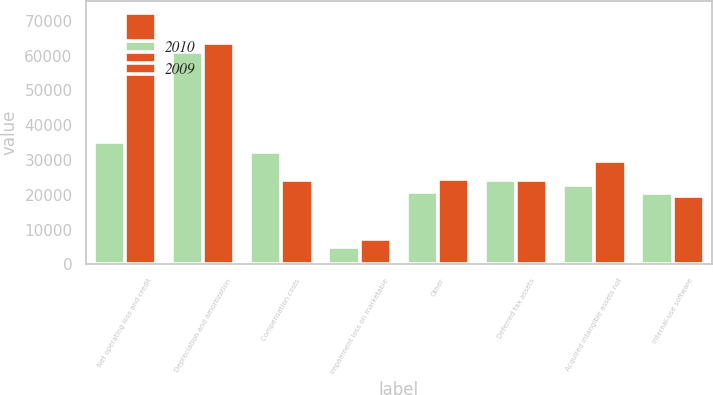Convert chart. <chart><loc_0><loc_0><loc_500><loc_500><stacked_bar_chart><ecel><fcel>Net operating loss and credit<fcel>Depreciation and amortization<fcel>Compensation costs<fcel>Impairment loss on marketable<fcel>Other<fcel>Deferred tax assets<fcel>Acquired intangible assets not<fcel>Internal-use software<nl><fcel>2010<fcel>35202<fcel>60935<fcel>32221<fcel>5005<fcel>20782<fcel>24368<fcel>22784<fcel>20527<nl><fcel>2009<fcel>72146<fcel>63709<fcel>24251<fcel>7345<fcel>24485<fcel>24368<fcel>29792<fcel>19632<nl></chart> 